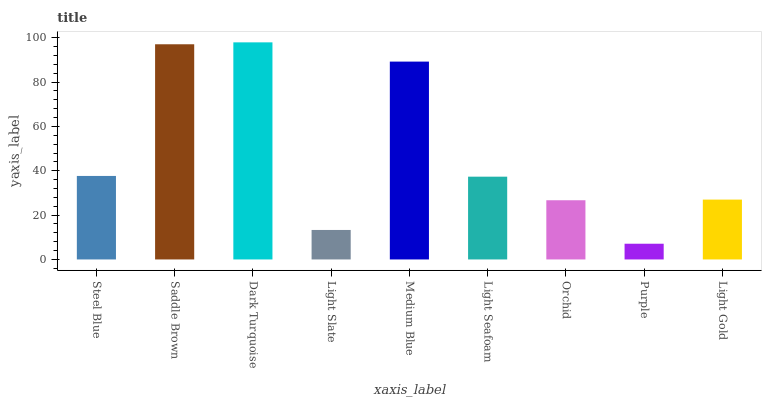Is Purple the minimum?
Answer yes or no. Yes. Is Dark Turquoise the maximum?
Answer yes or no. Yes. Is Saddle Brown the minimum?
Answer yes or no. No. Is Saddle Brown the maximum?
Answer yes or no. No. Is Saddle Brown greater than Steel Blue?
Answer yes or no. Yes. Is Steel Blue less than Saddle Brown?
Answer yes or no. Yes. Is Steel Blue greater than Saddle Brown?
Answer yes or no. No. Is Saddle Brown less than Steel Blue?
Answer yes or no. No. Is Light Seafoam the high median?
Answer yes or no. Yes. Is Light Seafoam the low median?
Answer yes or no. Yes. Is Medium Blue the high median?
Answer yes or no. No. Is Purple the low median?
Answer yes or no. No. 